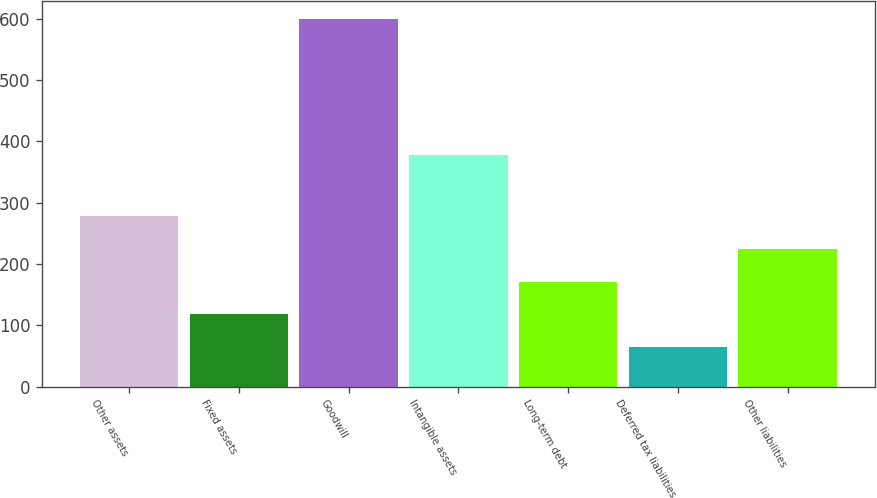Convert chart to OTSL. <chart><loc_0><loc_0><loc_500><loc_500><bar_chart><fcel>Other assets<fcel>Fixed assets<fcel>Goodwill<fcel>Intangible assets<fcel>Long-term debt<fcel>Deferred tax liabilities<fcel>Other liabilities<nl><fcel>278<fcel>117.5<fcel>599<fcel>377<fcel>171<fcel>64<fcel>224.5<nl></chart> 